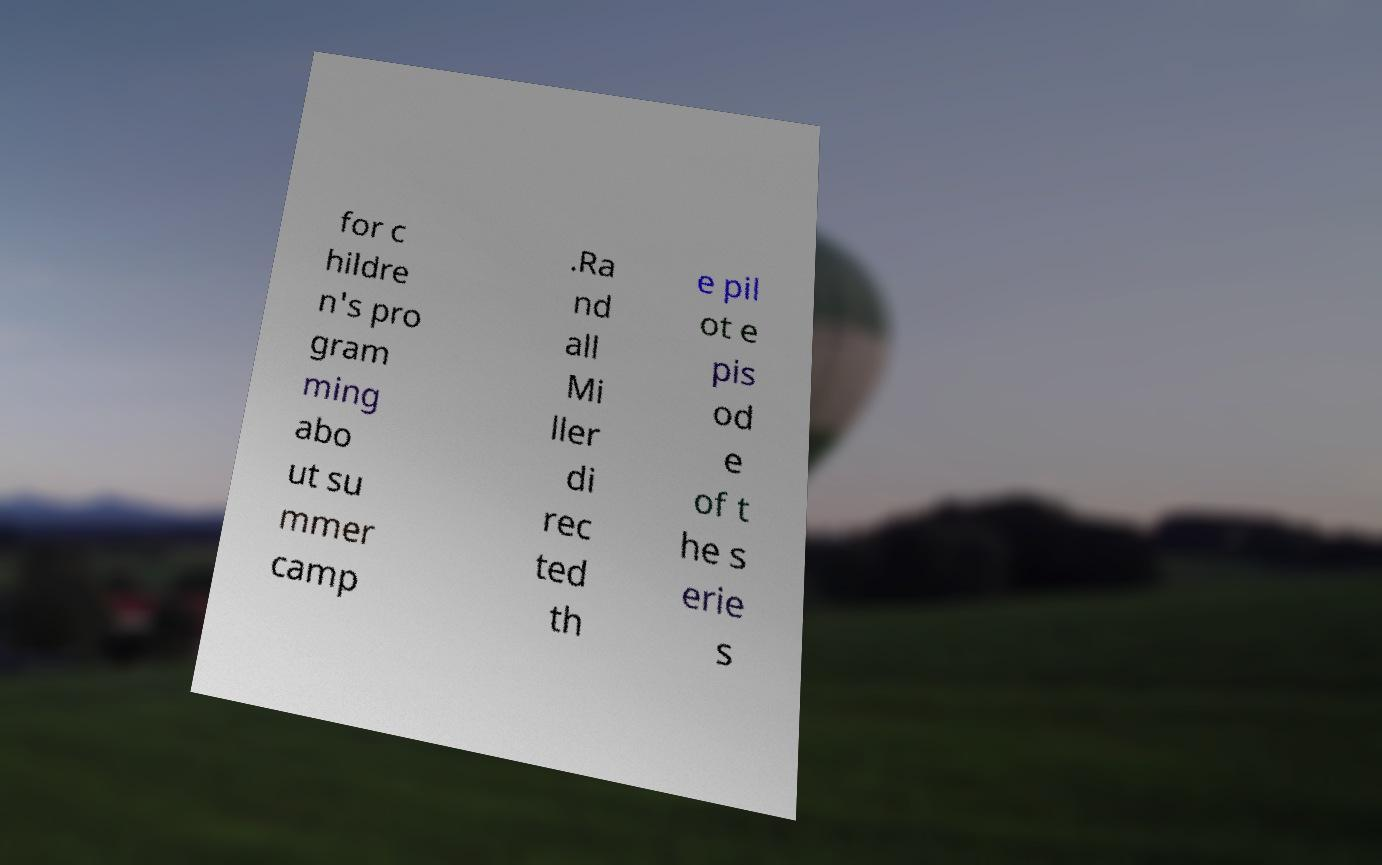Can you accurately transcribe the text from the provided image for me? for c hildre n's pro gram ming abo ut su mmer camp .Ra nd all Mi ller di rec ted th e pil ot e pis od e of t he s erie s 